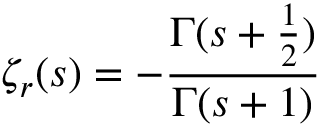Convert formula to latex. <formula><loc_0><loc_0><loc_500><loc_500>\zeta _ { r } ( s ) = - { \frac { \Gamma ( s + { \frac { 1 } { 2 } } ) } { \Gamma ( s + 1 ) } }</formula> 